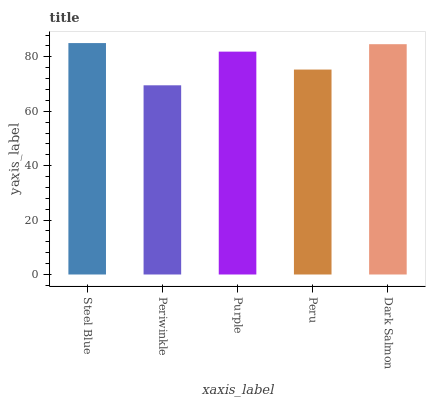Is Periwinkle the minimum?
Answer yes or no. Yes. Is Steel Blue the maximum?
Answer yes or no. Yes. Is Purple the minimum?
Answer yes or no. No. Is Purple the maximum?
Answer yes or no. No. Is Purple greater than Periwinkle?
Answer yes or no. Yes. Is Periwinkle less than Purple?
Answer yes or no. Yes. Is Periwinkle greater than Purple?
Answer yes or no. No. Is Purple less than Periwinkle?
Answer yes or no. No. Is Purple the high median?
Answer yes or no. Yes. Is Purple the low median?
Answer yes or no. Yes. Is Dark Salmon the high median?
Answer yes or no. No. Is Peru the low median?
Answer yes or no. No. 